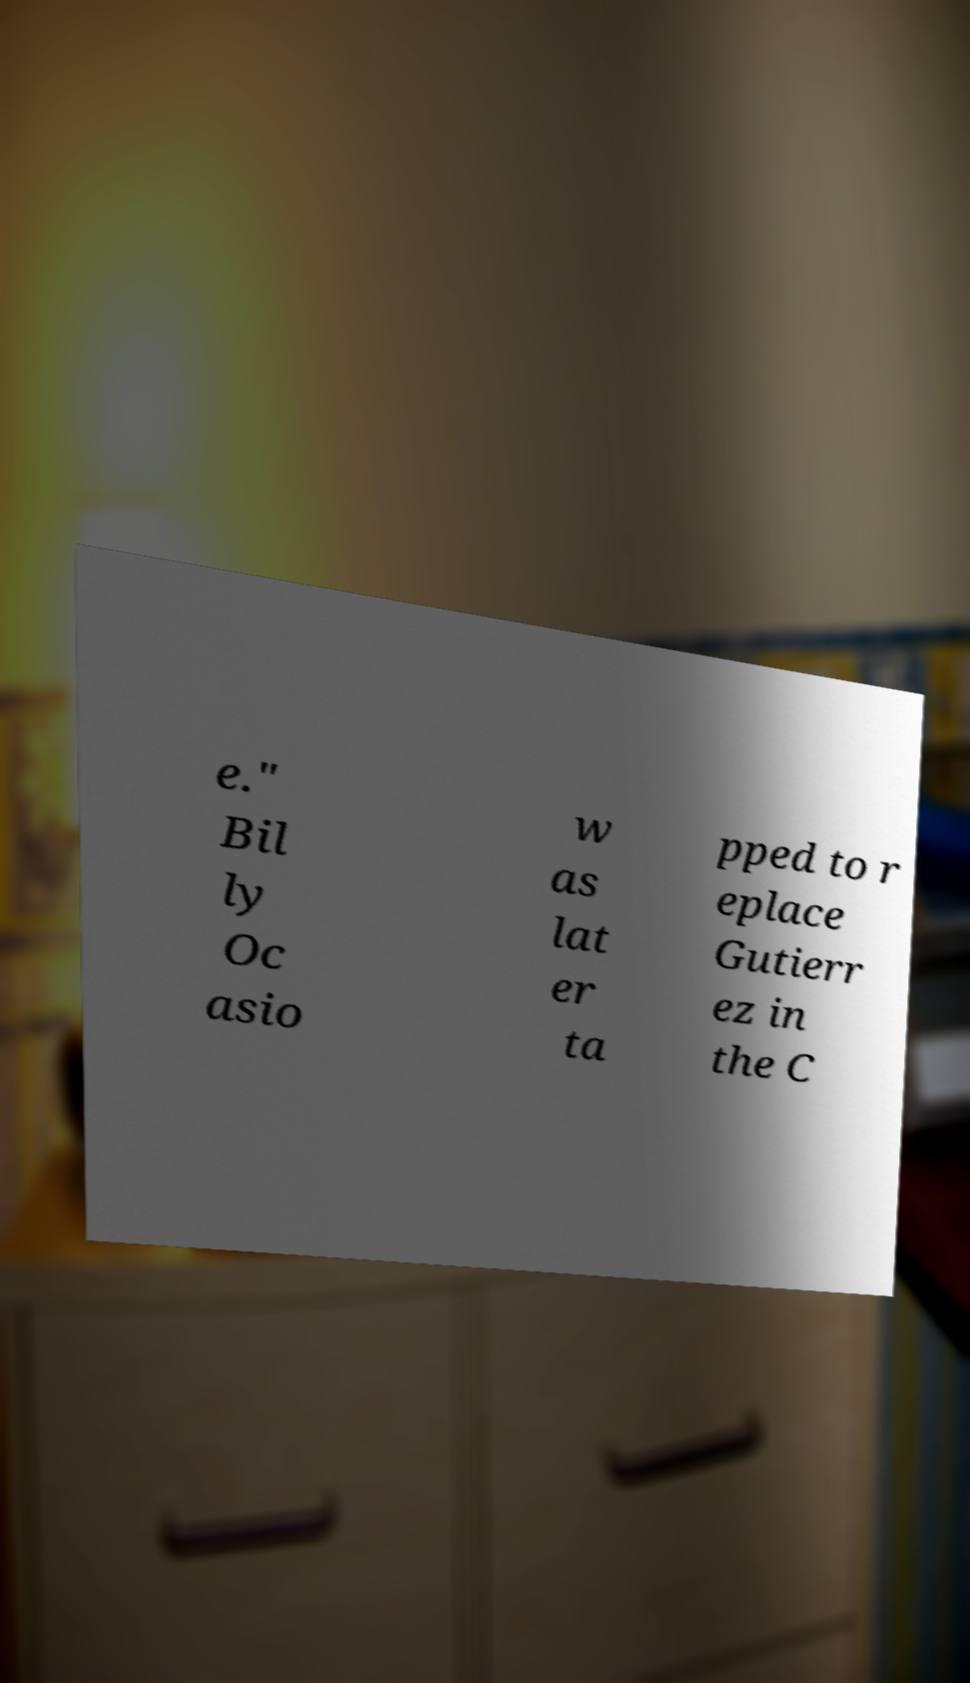Please identify and transcribe the text found in this image. e." Bil ly Oc asio w as lat er ta pped to r eplace Gutierr ez in the C 